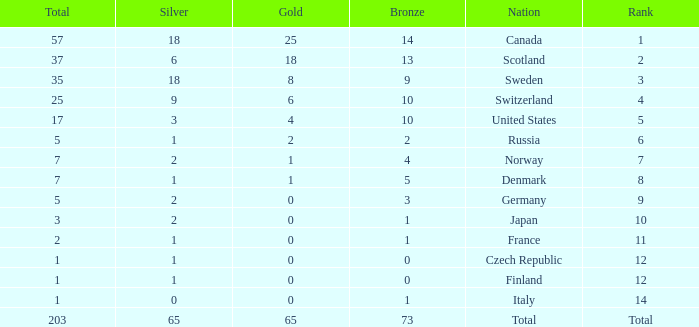What is the total number of medals when there are 18 gold medals? 37.0. 